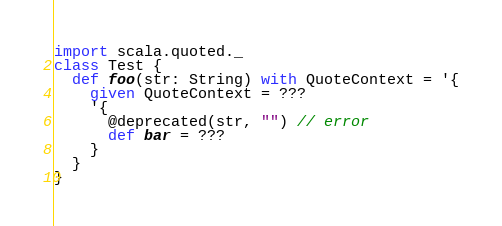Convert code to text. <code><loc_0><loc_0><loc_500><loc_500><_Scala_>import scala.quoted._
class Test {
  def foo(str: String) with QuoteContext = '{
    given QuoteContext = ???
    '{
      @deprecated(str, "") // error
      def bar = ???
    }
  }
}
</code> 